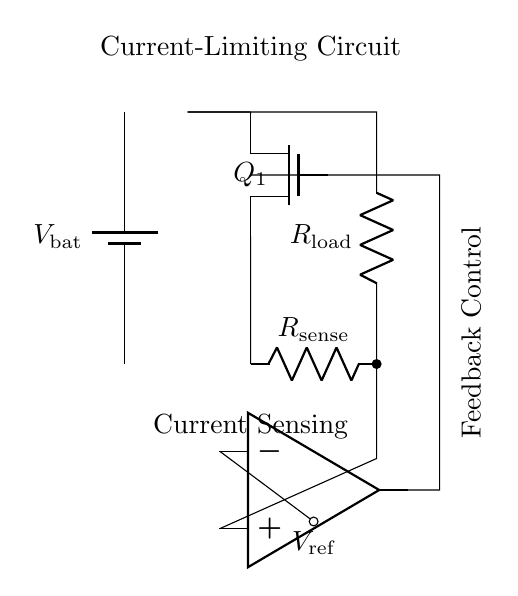What type of MOSFET is used in this circuit? The diagram specifies a Tnmos, which indicates a n-channel MOSFET used for current limiting in the circuit.
Answer: n-channel What component is used for current sensing? The circuit includes a resistor labeled as R-sense connected in series with the load, which is essential for measuring the current flowing through the circuit.
Answer: R-sense What does the operational amplifier do in this circuit? The operational amplifier compares the current through the R-sense with a reference voltage to control the gate of the MOSFET, thus regulating the current flowing through the load.
Answer: Current regulation What is the purpose of the feedback control label in this circuit? Feedback control refers to the mechanism by which the operational amplifier uses the sensed current to modulate the MOSFET's operation, ensuring that the load current does not exceed a predetermined limit.
Answer: Current limiting What voltage reference is present in the circuit? The circuit includes a reference voltage indicated as V-ref, which is used by the operational amplifier to determine the desired current threshold for regulation.
Answer: V-ref How is the load connected in the circuit? The load is connected in series with the R-sense resistor, and both are positioned between the battery and the current sensing path, illustrating the flow of current through the load during operation.
Answer: Series connection 